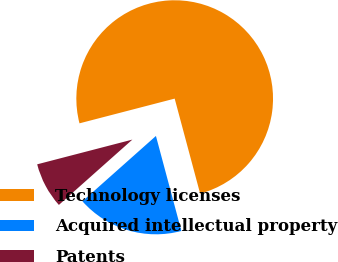<chart> <loc_0><loc_0><loc_500><loc_500><pie_chart><fcel>Technology licenses<fcel>Acquired intellectual property<fcel>Patents<nl><fcel>74.87%<fcel>17.6%<fcel>7.52%<nl></chart> 